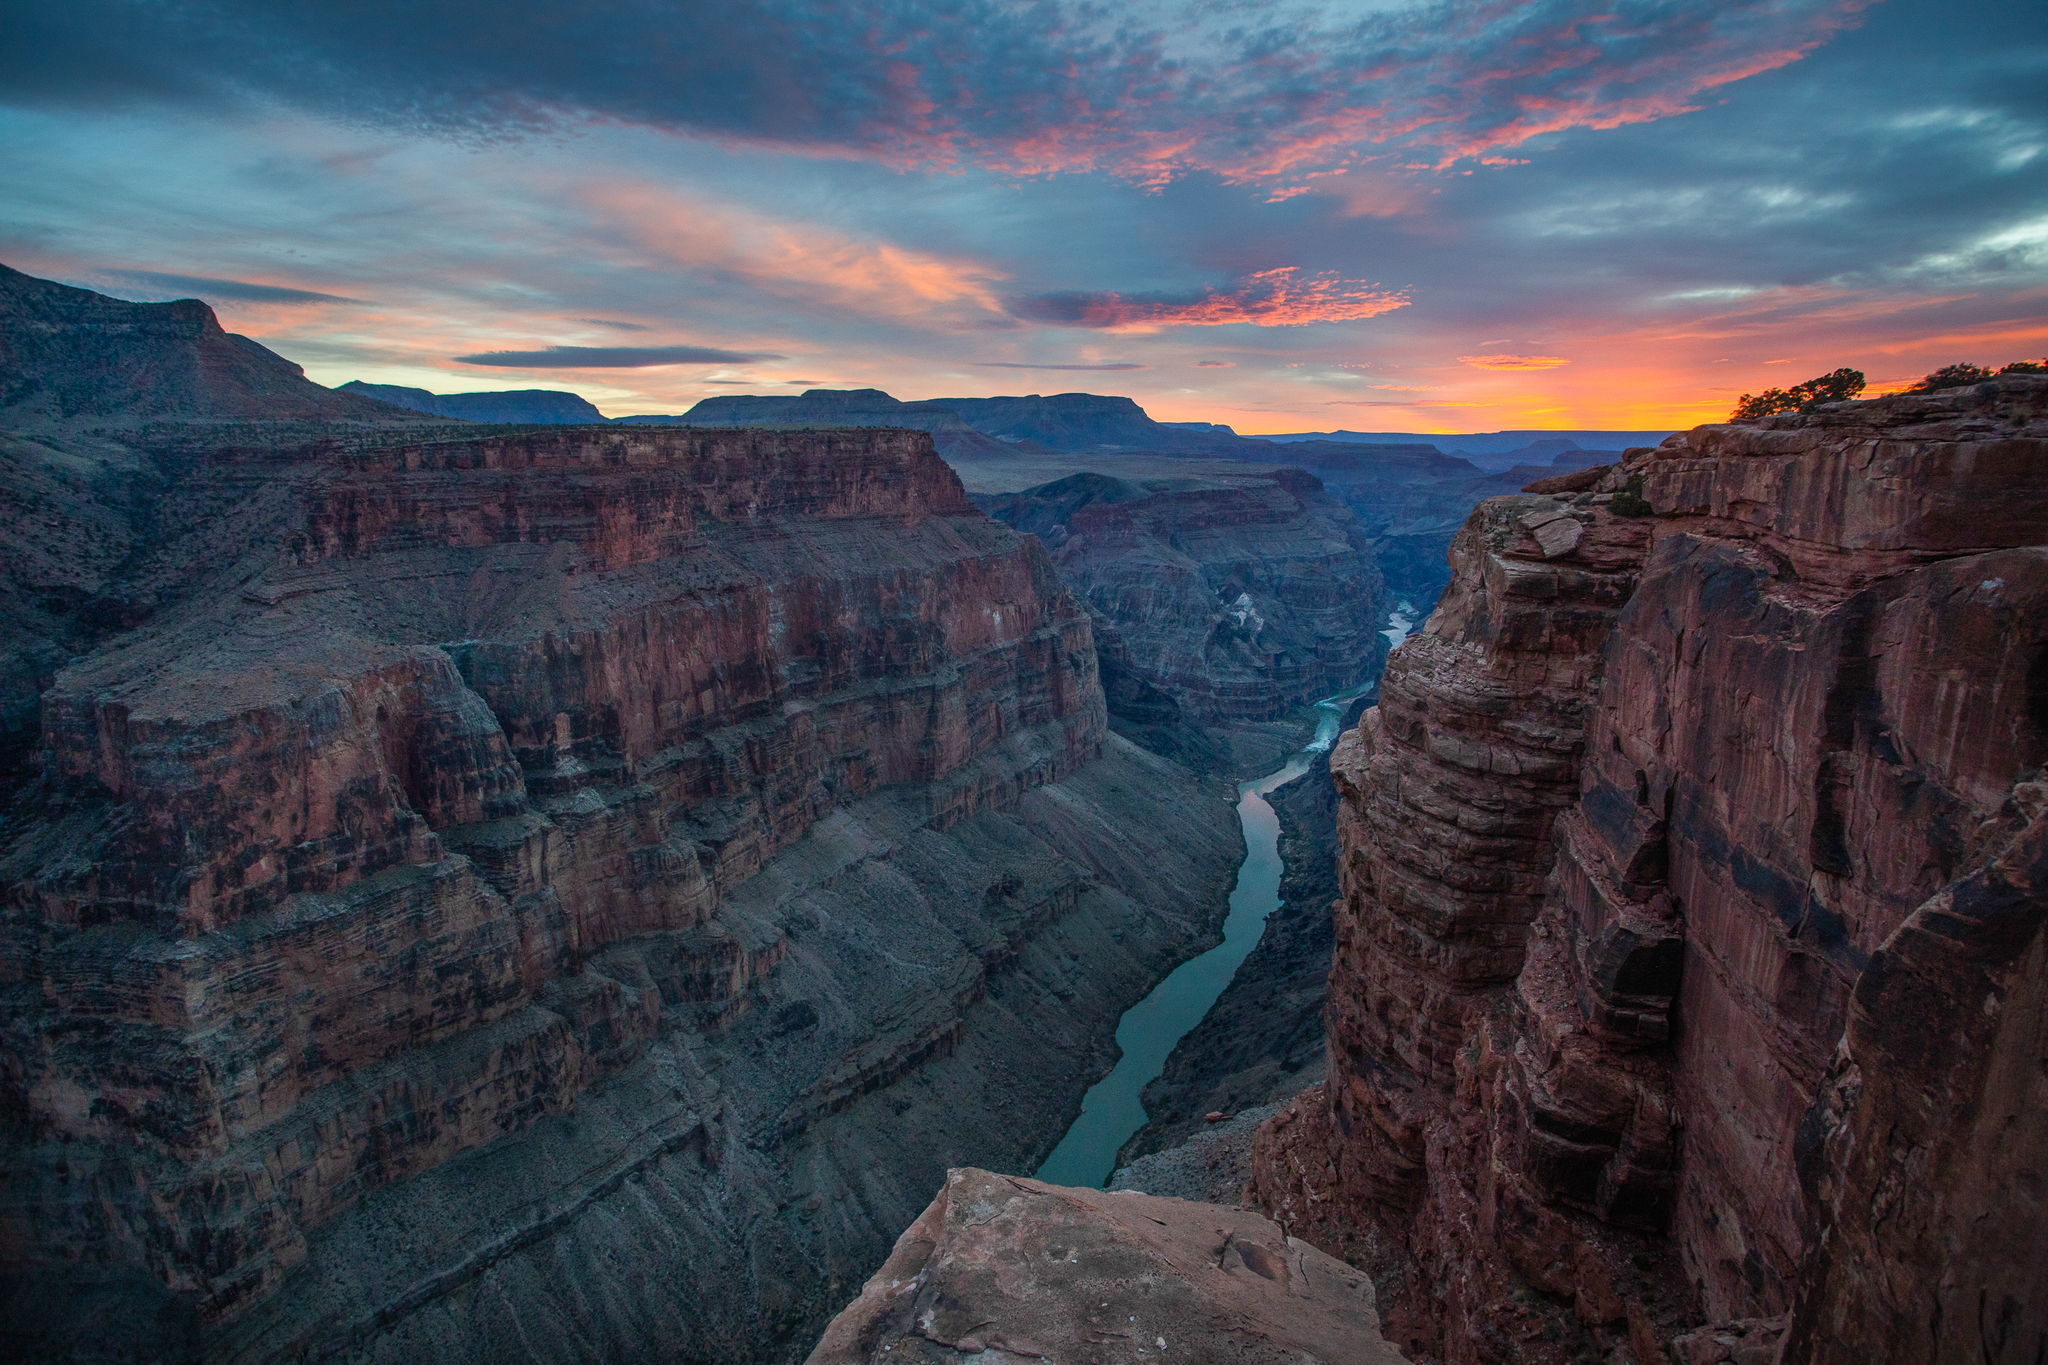What do you think is going on in this snapshot? This image offers a stunning view of the Grand Canyon during sunset. The Colorado River can be seen meandering through the canyon, emphasizing the immense scale and the deep, intricate erosions shaped over millions of years. The canyon walls glow with vibrant shades of red, orange, and brown, each layer telling a story of geological epochs. The sky, awash in a palette of pink and orange hues, reflects the setting sun's rays, casting a serene yet awe-inspiring light over the entire vista. This moment captures the profound beauty and grandeur of one of nature's most spectacular creations. 